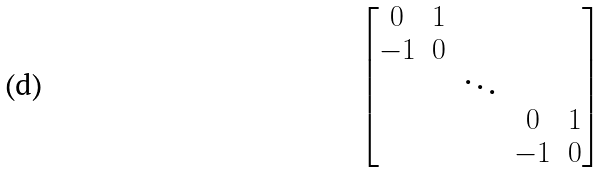Convert formula to latex. <formula><loc_0><loc_0><loc_500><loc_500>\begin{bmatrix} 0 & 1 \\ - 1 & 0 \\ & & \ddots \\ & & & 0 & 1 \\ & & & - 1 & 0 \end{bmatrix}</formula> 